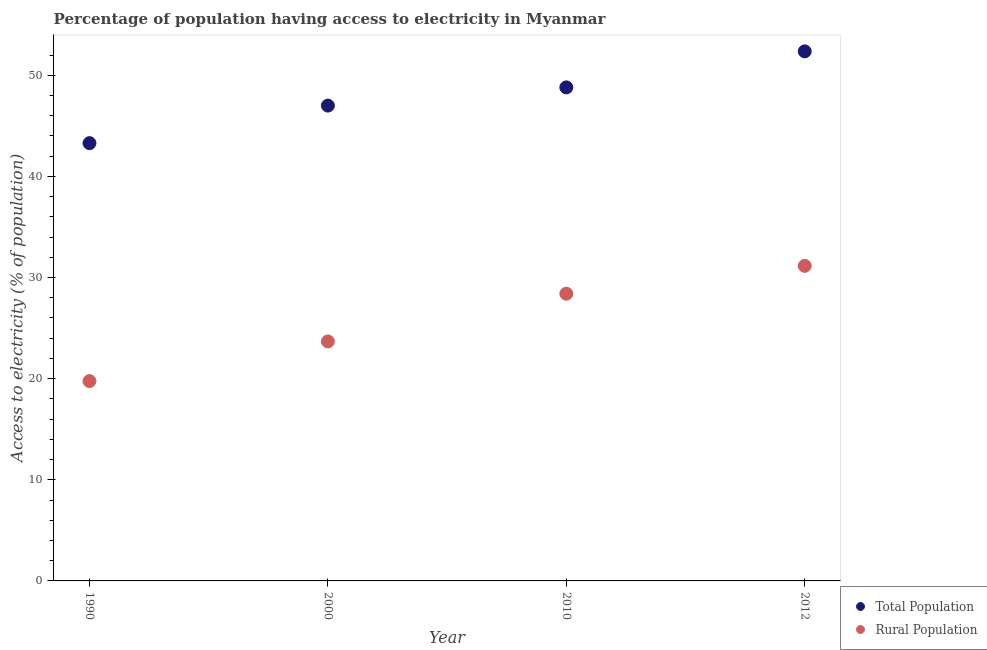What is the percentage of population having access to electricity in 2010?
Give a very brief answer. 48.8. Across all years, what is the maximum percentage of population having access to electricity?
Your answer should be compact. 52.36. Across all years, what is the minimum percentage of population having access to electricity?
Ensure brevity in your answer.  43.29. What is the total percentage of population having access to electricity in the graph?
Make the answer very short. 191.45. What is the difference between the percentage of population having access to electricity in 1990 and that in 2012?
Your response must be concise. -9.07. What is the difference between the percentage of rural population having access to electricity in 1990 and the percentage of population having access to electricity in 2012?
Your answer should be compact. -32.6. What is the average percentage of population having access to electricity per year?
Offer a terse response. 47.86. In the year 1990, what is the difference between the percentage of rural population having access to electricity and percentage of population having access to electricity?
Ensure brevity in your answer.  -23.53. In how many years, is the percentage of population having access to electricity greater than 36 %?
Keep it short and to the point. 4. What is the ratio of the percentage of rural population having access to electricity in 2000 to that in 2012?
Offer a terse response. 0.76. Is the percentage of rural population having access to electricity in 2000 less than that in 2010?
Give a very brief answer. Yes. What is the difference between the highest and the second highest percentage of population having access to electricity?
Your answer should be compact. 3.56. What is the difference between the highest and the lowest percentage of population having access to electricity?
Your response must be concise. 9.07. Does the percentage of population having access to electricity monotonically increase over the years?
Make the answer very short. Yes. How many dotlines are there?
Your answer should be very brief. 2. How many years are there in the graph?
Provide a succinct answer. 4. Does the graph contain any zero values?
Offer a terse response. No. How many legend labels are there?
Provide a succinct answer. 2. What is the title of the graph?
Ensure brevity in your answer.  Percentage of population having access to electricity in Myanmar. Does "From Government" appear as one of the legend labels in the graph?
Your answer should be very brief. No. What is the label or title of the Y-axis?
Provide a short and direct response. Access to electricity (% of population). What is the Access to electricity (% of population) of Total Population in 1990?
Your answer should be compact. 43.29. What is the Access to electricity (% of population) in Rural Population in 1990?
Keep it short and to the point. 19.76. What is the Access to electricity (% of population) of Total Population in 2000?
Provide a short and direct response. 47. What is the Access to electricity (% of population) in Rural Population in 2000?
Offer a very short reply. 23.68. What is the Access to electricity (% of population) of Total Population in 2010?
Your response must be concise. 48.8. What is the Access to electricity (% of population) in Rural Population in 2010?
Keep it short and to the point. 28.4. What is the Access to electricity (% of population) of Total Population in 2012?
Ensure brevity in your answer.  52.36. What is the Access to electricity (% of population) in Rural Population in 2012?
Offer a very short reply. 31.15. Across all years, what is the maximum Access to electricity (% of population) of Total Population?
Your answer should be compact. 52.36. Across all years, what is the maximum Access to electricity (% of population) of Rural Population?
Provide a succinct answer. 31.15. Across all years, what is the minimum Access to electricity (% of population) in Total Population?
Give a very brief answer. 43.29. Across all years, what is the minimum Access to electricity (% of population) in Rural Population?
Make the answer very short. 19.76. What is the total Access to electricity (% of population) of Total Population in the graph?
Offer a very short reply. 191.45. What is the total Access to electricity (% of population) in Rural Population in the graph?
Provide a short and direct response. 103. What is the difference between the Access to electricity (% of population) in Total Population in 1990 and that in 2000?
Give a very brief answer. -3.71. What is the difference between the Access to electricity (% of population) in Rural Population in 1990 and that in 2000?
Your answer should be compact. -3.92. What is the difference between the Access to electricity (% of population) in Total Population in 1990 and that in 2010?
Your answer should be compact. -5.51. What is the difference between the Access to electricity (% of population) of Rural Population in 1990 and that in 2010?
Your answer should be compact. -8.64. What is the difference between the Access to electricity (% of population) in Total Population in 1990 and that in 2012?
Offer a terse response. -9.07. What is the difference between the Access to electricity (% of population) in Rural Population in 1990 and that in 2012?
Your response must be concise. -11.39. What is the difference between the Access to electricity (% of population) of Total Population in 2000 and that in 2010?
Your answer should be very brief. -1.8. What is the difference between the Access to electricity (% of population) of Rural Population in 2000 and that in 2010?
Ensure brevity in your answer.  -4.72. What is the difference between the Access to electricity (% of population) in Total Population in 2000 and that in 2012?
Your response must be concise. -5.36. What is the difference between the Access to electricity (% of population) in Rural Population in 2000 and that in 2012?
Make the answer very short. -7.47. What is the difference between the Access to electricity (% of population) of Total Population in 2010 and that in 2012?
Ensure brevity in your answer.  -3.56. What is the difference between the Access to electricity (% of population) in Rural Population in 2010 and that in 2012?
Ensure brevity in your answer.  -2.75. What is the difference between the Access to electricity (% of population) of Total Population in 1990 and the Access to electricity (% of population) of Rural Population in 2000?
Your response must be concise. 19.61. What is the difference between the Access to electricity (% of population) of Total Population in 1990 and the Access to electricity (% of population) of Rural Population in 2010?
Provide a succinct answer. 14.89. What is the difference between the Access to electricity (% of population) in Total Population in 1990 and the Access to electricity (% of population) in Rural Population in 2012?
Provide a succinct answer. 12.13. What is the difference between the Access to electricity (% of population) in Total Population in 2000 and the Access to electricity (% of population) in Rural Population in 2010?
Give a very brief answer. 18.6. What is the difference between the Access to electricity (% of population) of Total Population in 2000 and the Access to electricity (% of population) of Rural Population in 2012?
Provide a succinct answer. 15.85. What is the difference between the Access to electricity (% of population) of Total Population in 2010 and the Access to electricity (% of population) of Rural Population in 2012?
Your answer should be compact. 17.65. What is the average Access to electricity (% of population) of Total Population per year?
Give a very brief answer. 47.86. What is the average Access to electricity (% of population) of Rural Population per year?
Your answer should be compact. 25.75. In the year 1990, what is the difference between the Access to electricity (% of population) in Total Population and Access to electricity (% of population) in Rural Population?
Offer a very short reply. 23.53. In the year 2000, what is the difference between the Access to electricity (% of population) of Total Population and Access to electricity (% of population) of Rural Population?
Give a very brief answer. 23.32. In the year 2010, what is the difference between the Access to electricity (% of population) of Total Population and Access to electricity (% of population) of Rural Population?
Ensure brevity in your answer.  20.4. In the year 2012, what is the difference between the Access to electricity (% of population) in Total Population and Access to electricity (% of population) in Rural Population?
Ensure brevity in your answer.  21.21. What is the ratio of the Access to electricity (% of population) of Total Population in 1990 to that in 2000?
Make the answer very short. 0.92. What is the ratio of the Access to electricity (% of population) in Rural Population in 1990 to that in 2000?
Your answer should be compact. 0.83. What is the ratio of the Access to electricity (% of population) in Total Population in 1990 to that in 2010?
Offer a terse response. 0.89. What is the ratio of the Access to electricity (% of population) of Rural Population in 1990 to that in 2010?
Offer a terse response. 0.7. What is the ratio of the Access to electricity (% of population) in Total Population in 1990 to that in 2012?
Provide a short and direct response. 0.83. What is the ratio of the Access to electricity (% of population) in Rural Population in 1990 to that in 2012?
Give a very brief answer. 0.63. What is the ratio of the Access to electricity (% of population) in Total Population in 2000 to that in 2010?
Your response must be concise. 0.96. What is the ratio of the Access to electricity (% of population) of Rural Population in 2000 to that in 2010?
Offer a terse response. 0.83. What is the ratio of the Access to electricity (% of population) of Total Population in 2000 to that in 2012?
Make the answer very short. 0.9. What is the ratio of the Access to electricity (% of population) in Rural Population in 2000 to that in 2012?
Offer a terse response. 0.76. What is the ratio of the Access to electricity (% of population) of Total Population in 2010 to that in 2012?
Provide a succinct answer. 0.93. What is the ratio of the Access to electricity (% of population) of Rural Population in 2010 to that in 2012?
Make the answer very short. 0.91. What is the difference between the highest and the second highest Access to electricity (% of population) in Total Population?
Your response must be concise. 3.56. What is the difference between the highest and the second highest Access to electricity (% of population) in Rural Population?
Your response must be concise. 2.75. What is the difference between the highest and the lowest Access to electricity (% of population) in Total Population?
Keep it short and to the point. 9.07. What is the difference between the highest and the lowest Access to electricity (% of population) in Rural Population?
Your response must be concise. 11.39. 